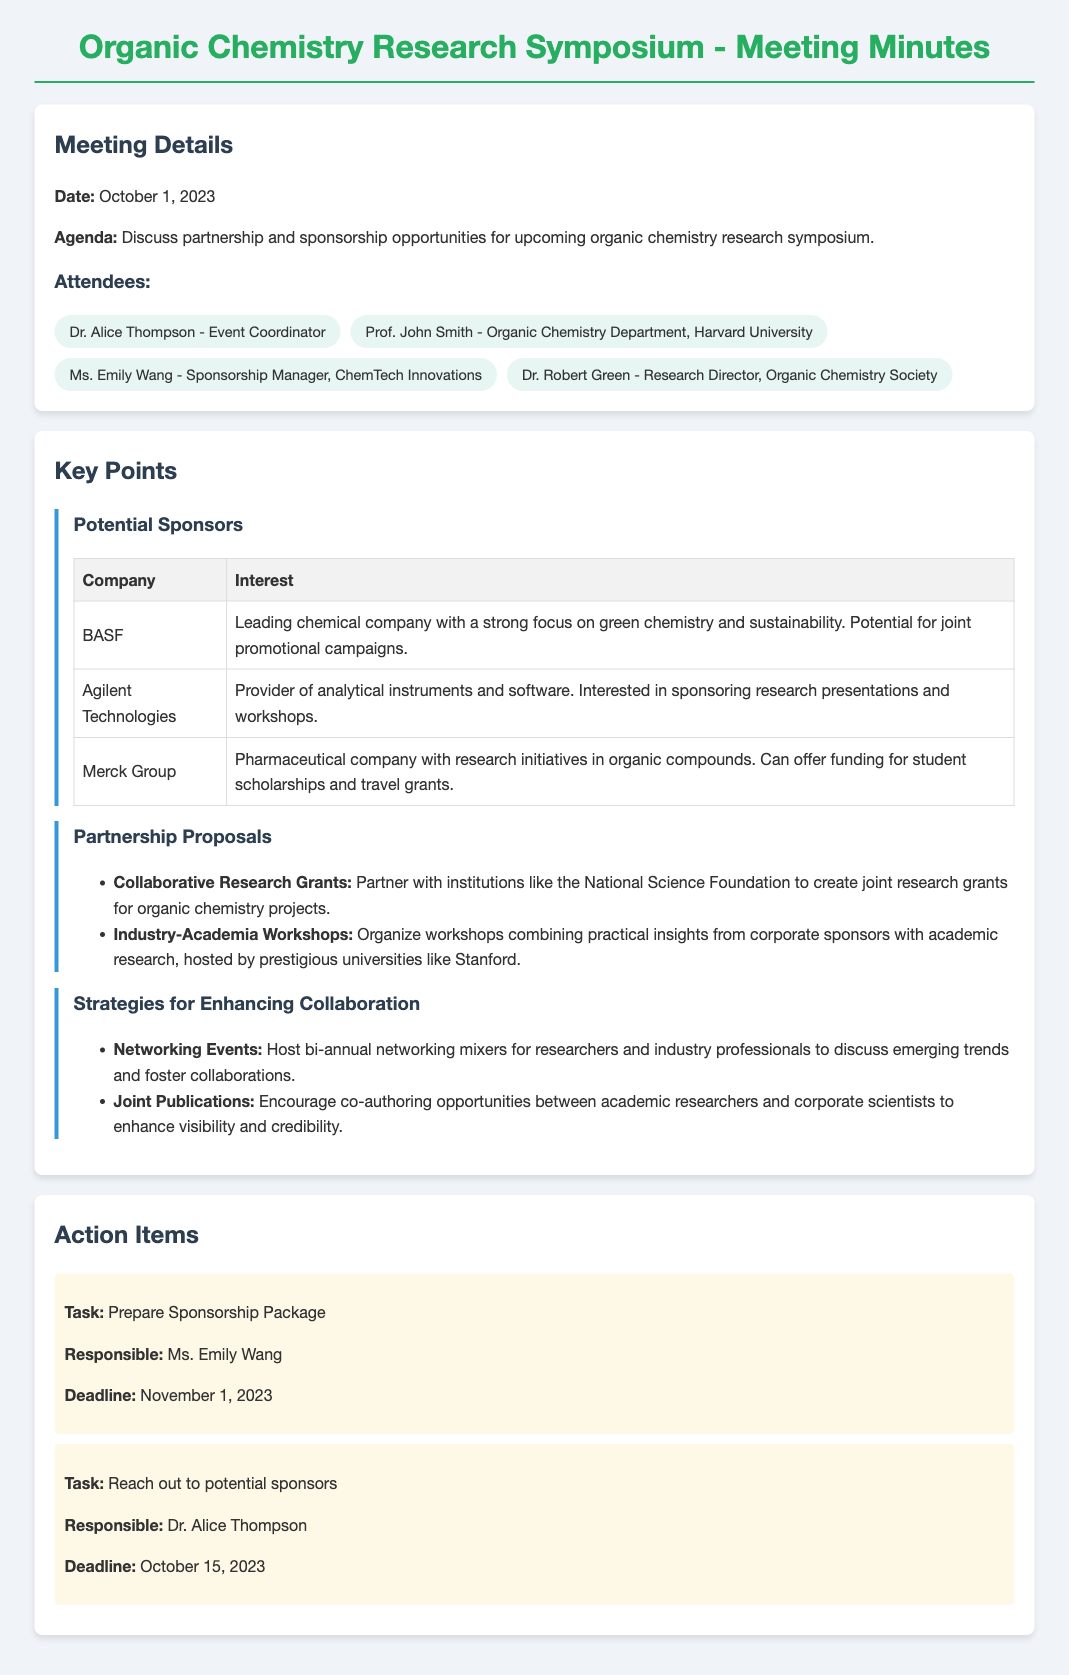What is the date of the meeting? The document states that the meeting took place on October 1, 2023.
Answer: October 1, 2023 Who is the event coordinator? The document lists Dr. Alice Thompson as the event coordinator.
Answer: Dr. Alice Thompson Which company has an interest in sponsoring research presentations? Agilent Technologies is noted for sponsoring research presentations and workshops.
Answer: Agilent Technologies What is a proposed partnership with the National Science Foundation? The meeting minutes suggest creating joint research grants for organic chemistry projects with the National Science Foundation.
Answer: Collaborative Research Grants What is the deadline for preparing the sponsorship package? The action item states that the deadline to prepare the sponsorship package is November 1, 2023.
Answer: November 1, 2023 Which company is identified as having a strong focus on green chemistry? BASF is described as a leading chemical company with a focus on green chemistry and sustainability.
Answer: BASF What is one strategy suggested for enhancing collaboration? The document includes hosting bi-annual networking mixers as a strategy for enhancing collaboration.
Answer: Networking Events What task is assigned to Dr. Alice Thompson? Dr. Alice Thompson is responsible for reaching out to potential sponsors.
Answer: Reach out to potential sponsors 